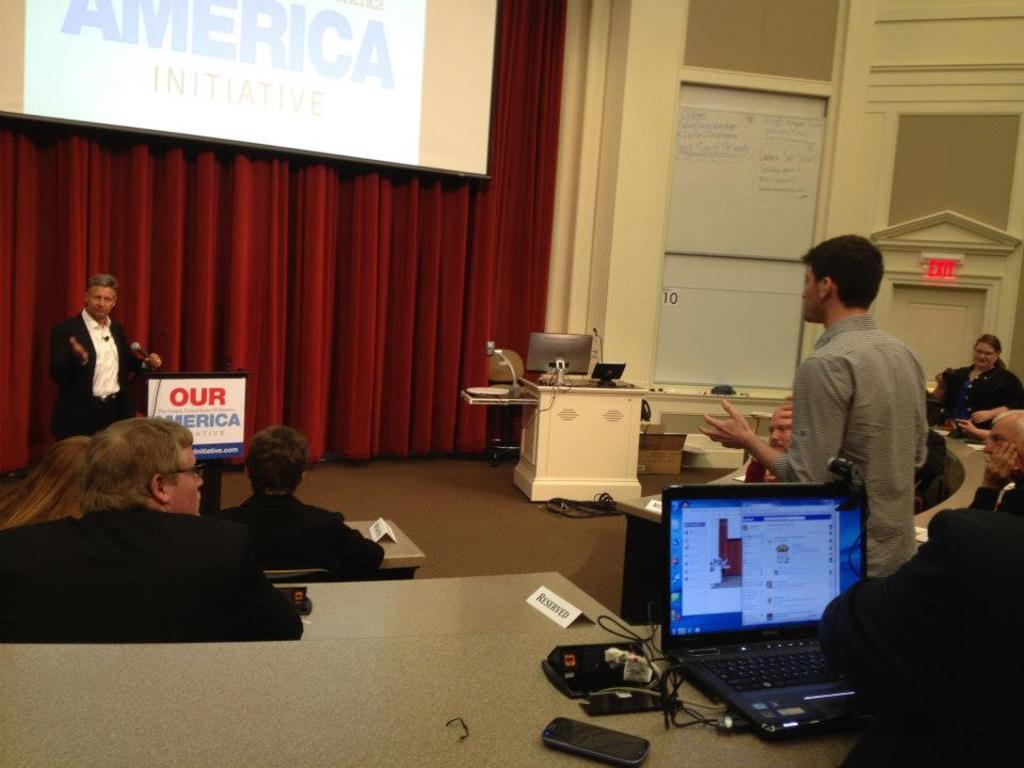What country is this politician representing?
Offer a terse response. America. Our america is a?
Give a very brief answer. Initiative. 